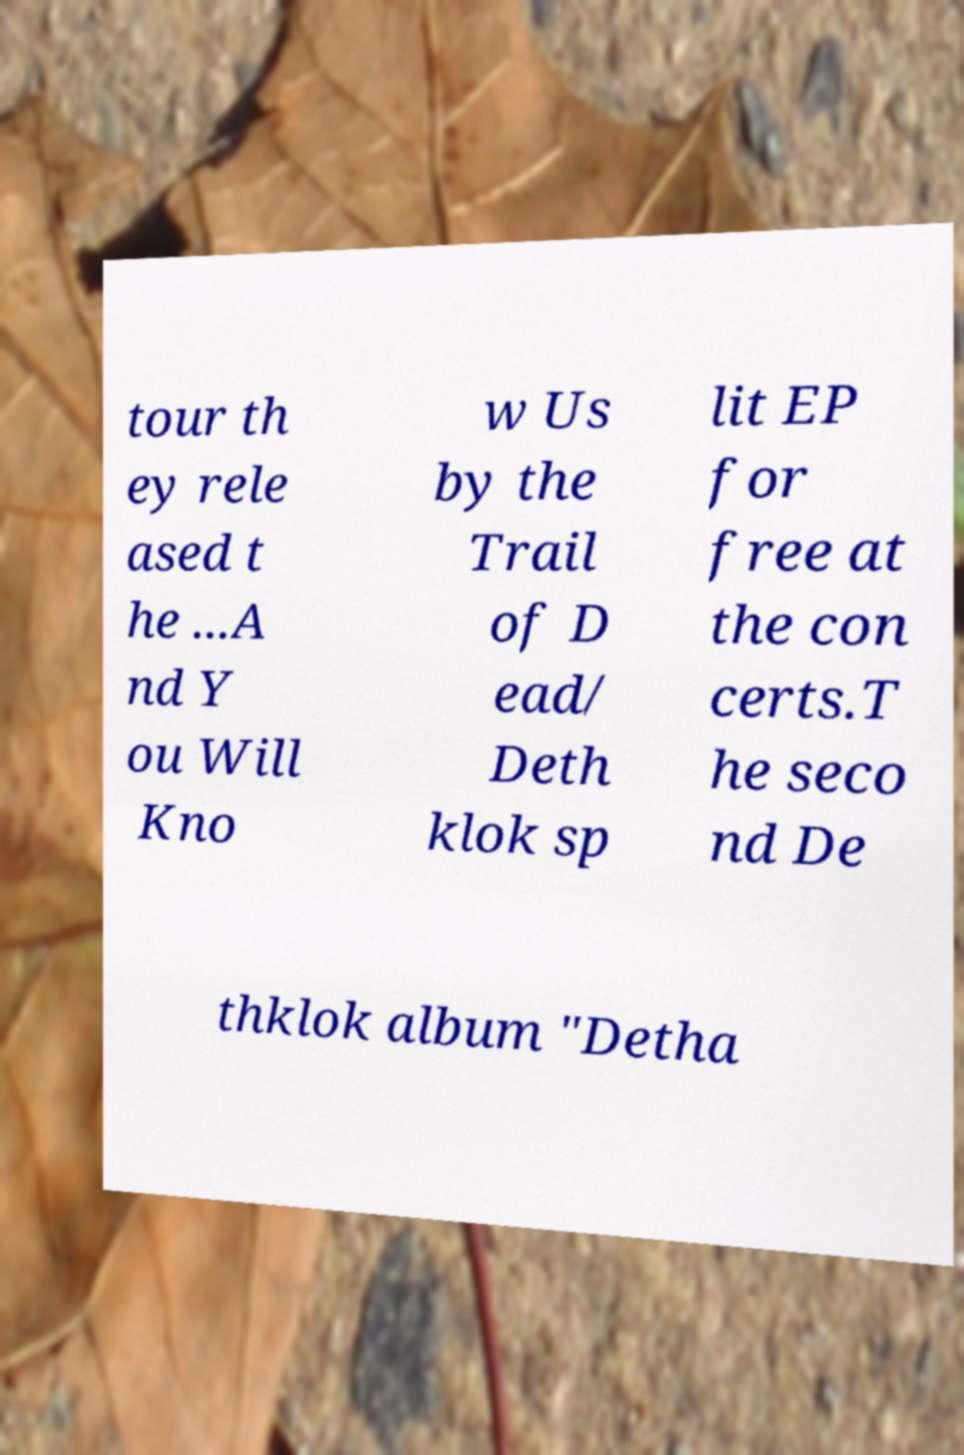What messages or text are displayed in this image? I need them in a readable, typed format. tour th ey rele ased t he ...A nd Y ou Will Kno w Us by the Trail of D ead/ Deth klok sp lit EP for free at the con certs.T he seco nd De thklok album "Detha 